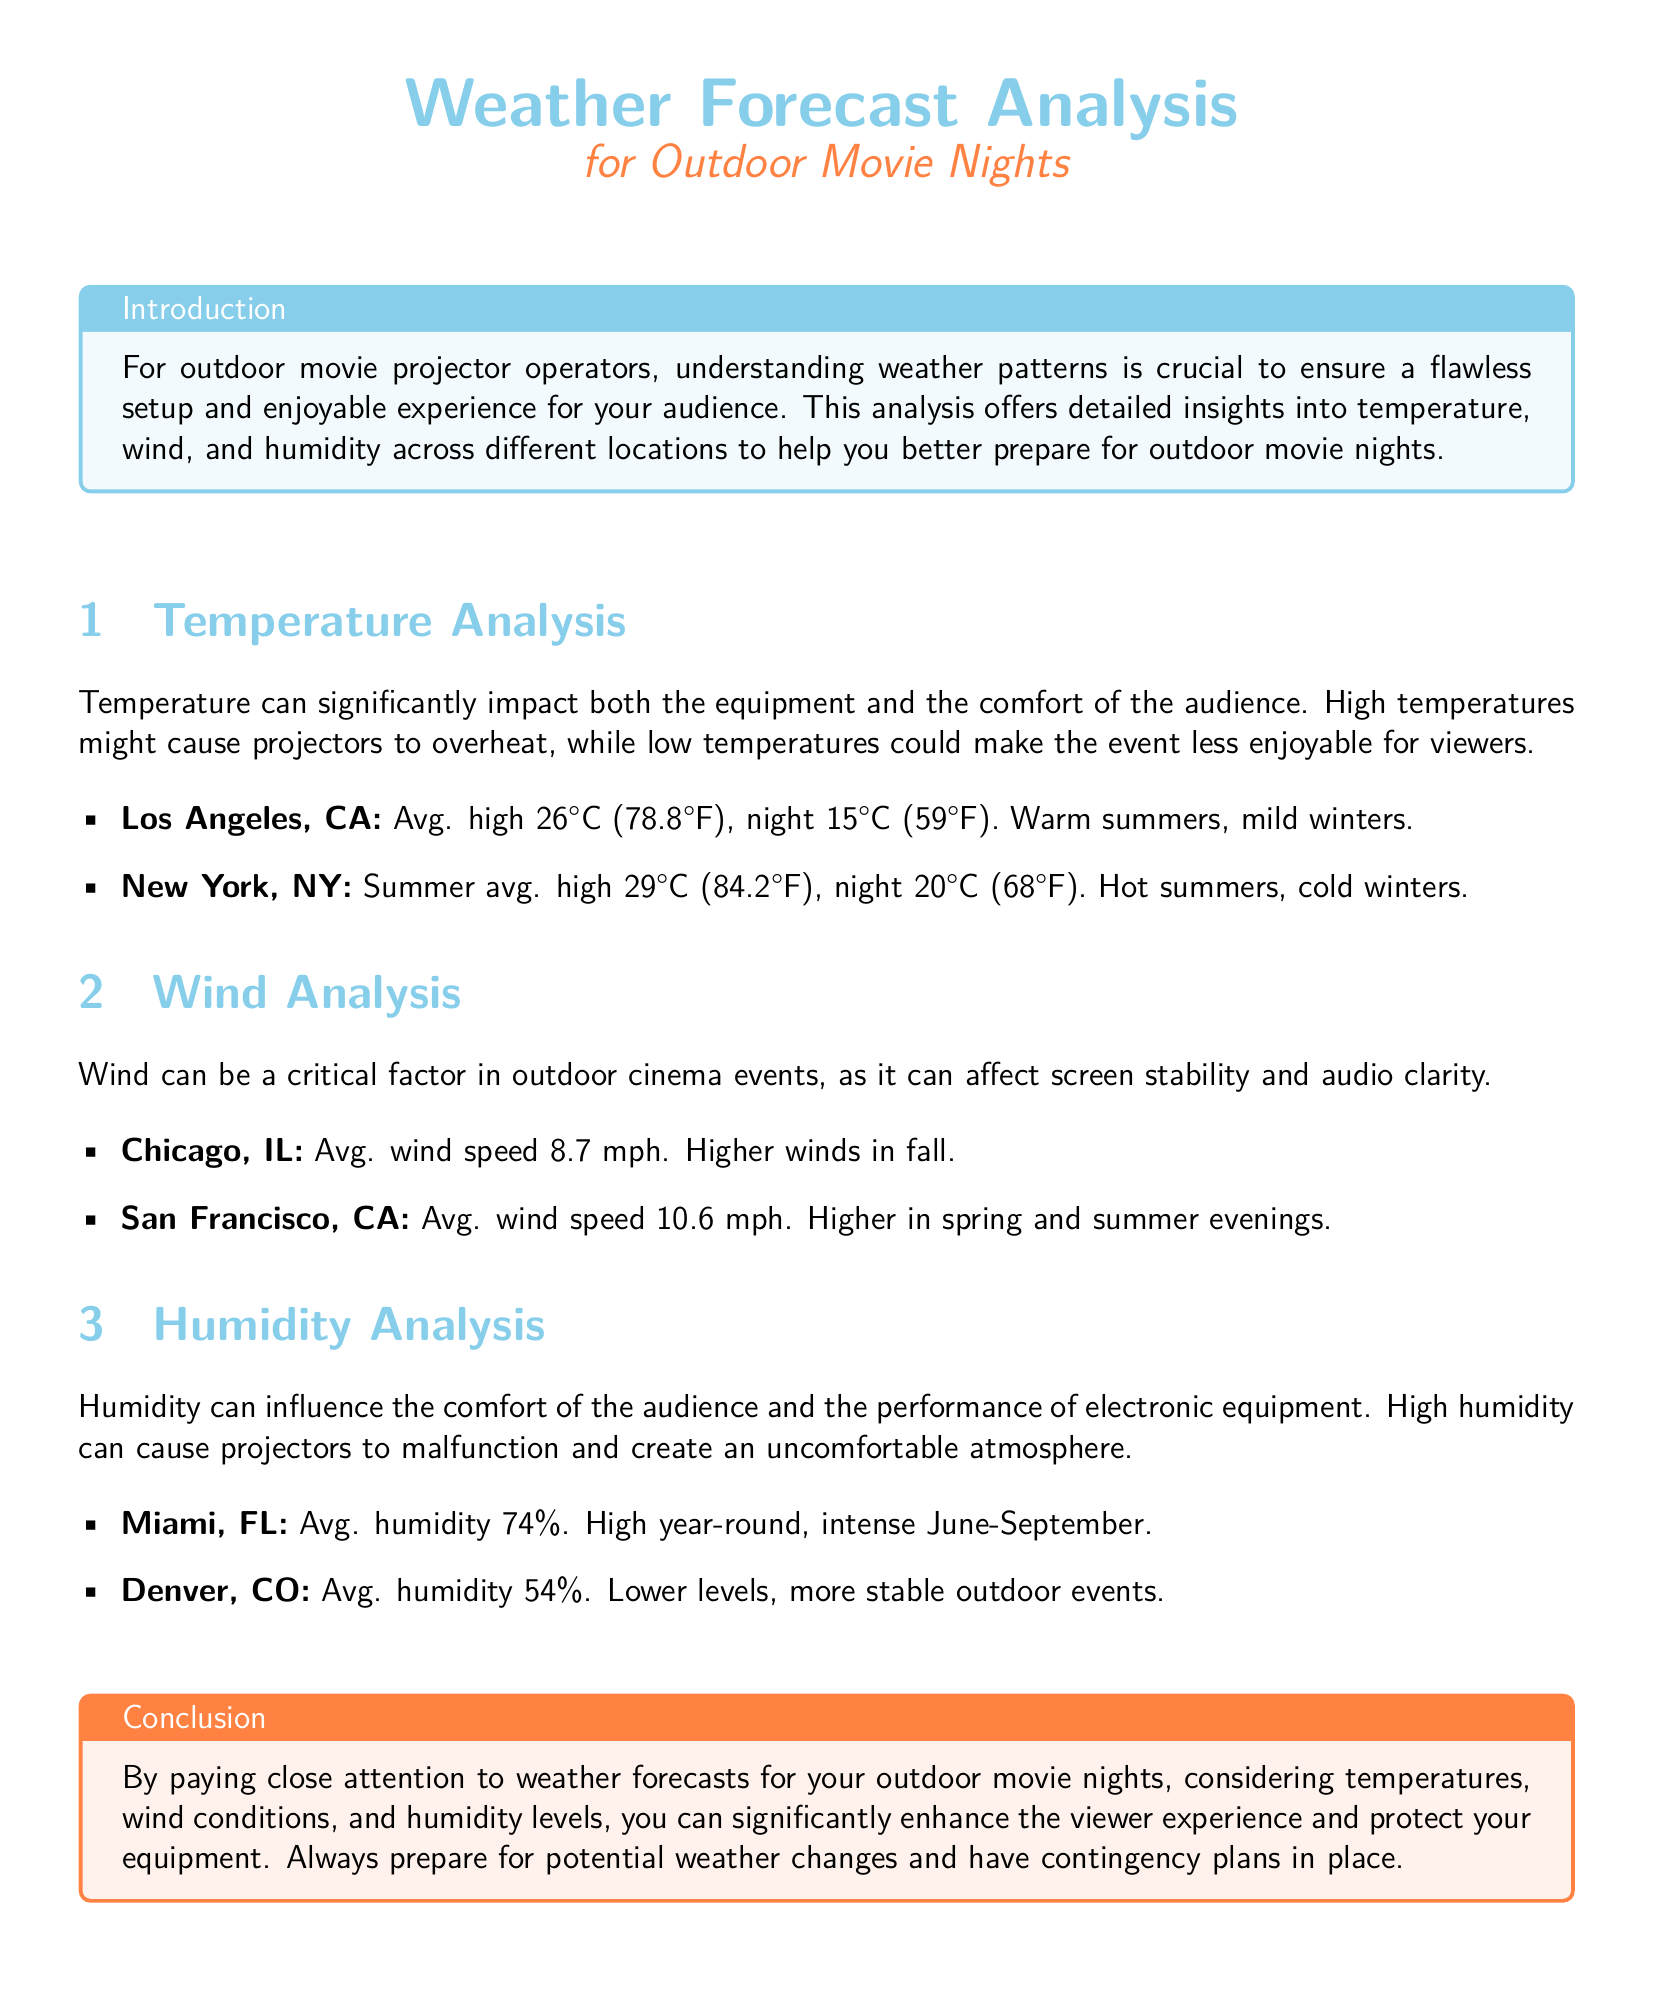What is the average high temperature in Los Angeles? The average high temperature in Los Angeles is stated as 26°C (78.8°F) in the document.
Answer: 26°C (78.8°F) What is the average wind speed in Chicago? The document notes that the average wind speed in Chicago is 8.7 mph.
Answer: 8.7 mph What humidity level is typical for Miami? The average humidity for Miami mentioned in the document is 74%.
Answer: 74% During which months does Miami experience intense humidity? The document specifies that Miami has intense humidity from June to September.
Answer: June-September Which city has the highest average humidity? The document indicates that Miami has the highest average humidity at 74%.
Answer: Miami What is the average night temperature in New York? The average night temperature in New York is given as 20°C (68°F) in the document.
Answer: 20°C (68°F) How does wind speed in San Francisco compare to Chicago? The document states that San Francisco has a higher average wind speed of 10.6 mph compared to Chicago's 8.7 mph.
Answer: San Francisco In what season does Chicago experience higher winds? The document notes that Chicago experiences higher winds in fall.
Answer: Fall What is the purpose of the document? The document aims to provide insights for outdoor movie projector operators regarding weather conditions.
Answer: Insights for outdoor movie projector operators 